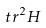Convert formula to latex. <formula><loc_0><loc_0><loc_500><loc_500>t r ^ { 2 } H</formula> 